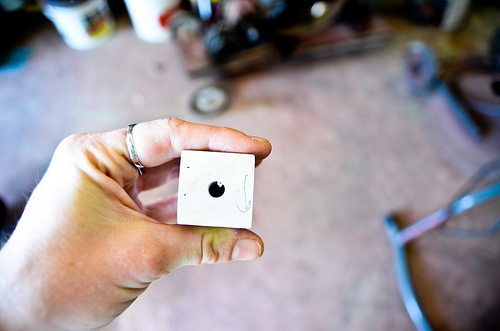<image>
Is there a cube above the ground? Yes. The cube is positioned above the ground in the vertical space, higher up in the scene. 